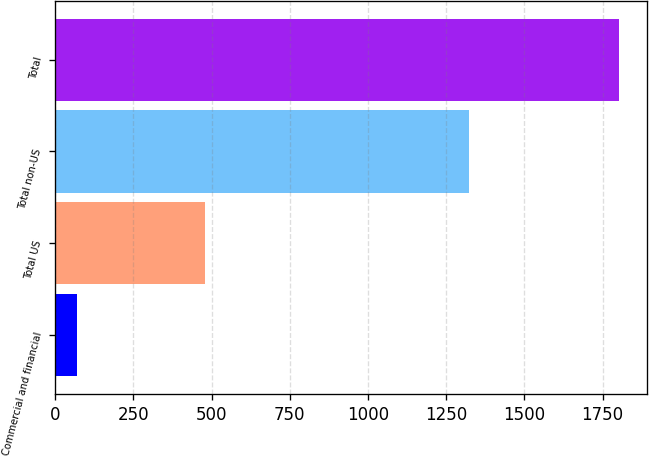Convert chart. <chart><loc_0><loc_0><loc_500><loc_500><bar_chart><fcel>Commercial and financial<fcel>Total US<fcel>Total non-US<fcel>Total<nl><fcel>71<fcel>479<fcel>1323<fcel>1802<nl></chart> 